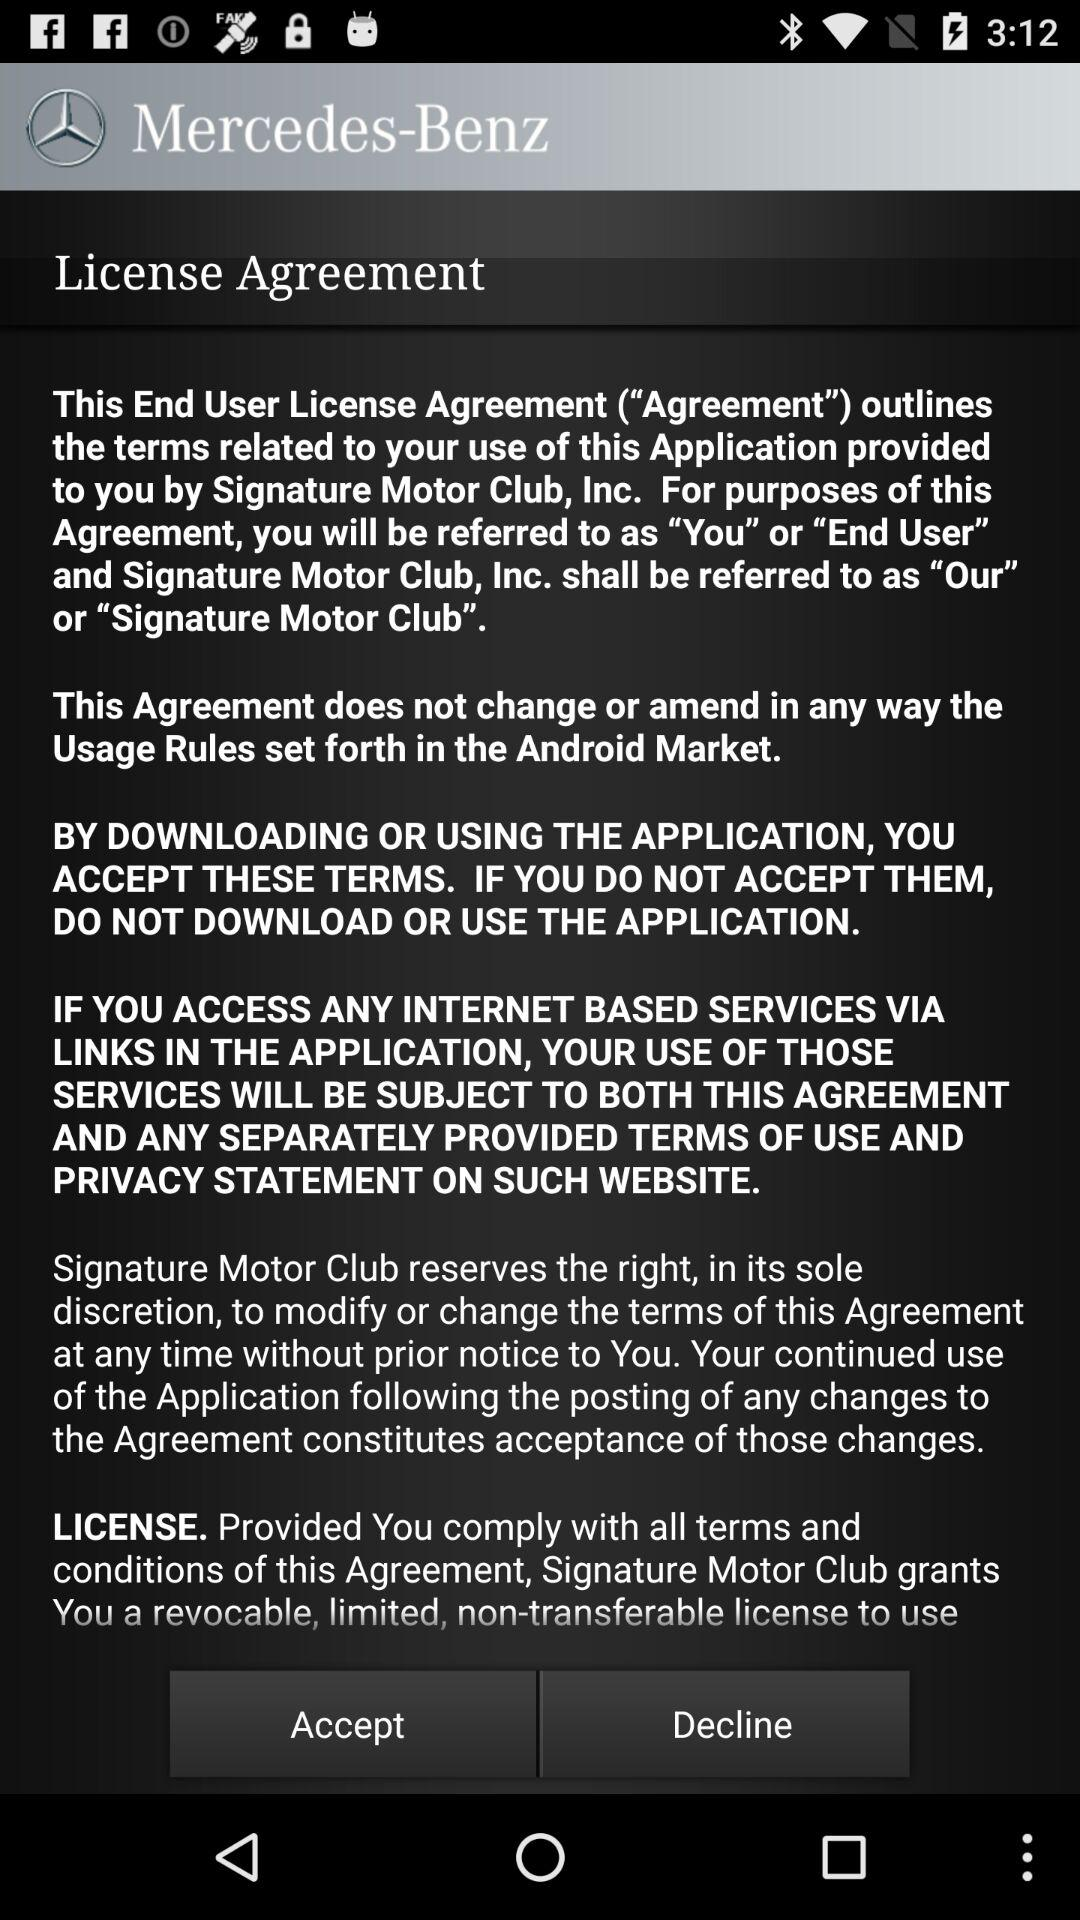What is the application name? The application name is "Mercedes-Benz". 